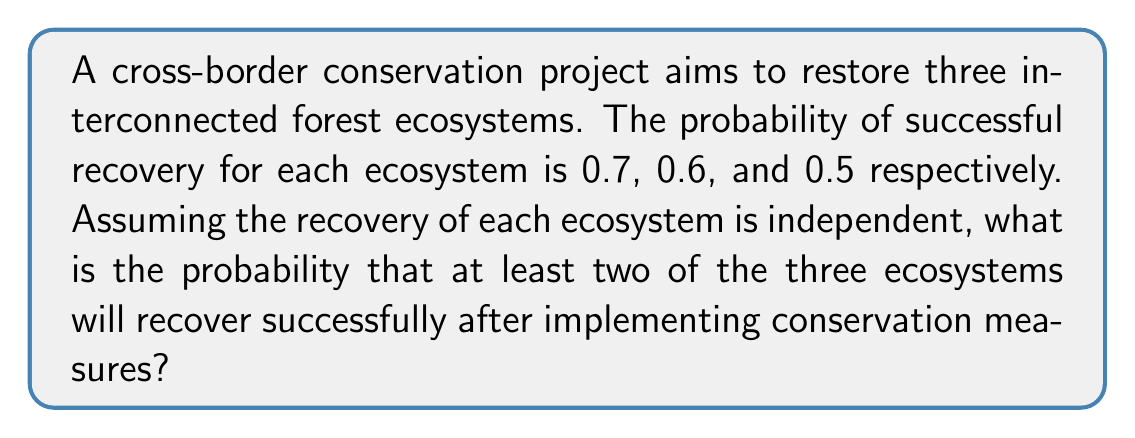Teach me how to tackle this problem. Let's approach this step-by-step:

1) First, we need to calculate the probability of the complement event: the probability that 0 or 1 ecosystem recovers.

2) Let's define the events:
   A: first ecosystem recovers (P(A) = 0.7)
   B: second ecosystem recovers (P(B) = 0.6)
   C: third ecosystem recovers (P(C) = 0.5)

3) Probability of 0 ecosystems recovering:
   $P(\text{none}) = (1-0.7)(1-0.6)(1-0.5) = 0.3 \times 0.4 \times 0.5 = 0.06$

4) Probability of exactly 1 ecosystem recovering:
   $P(\text{one}) = 0.7 \times 0.4 \times 0.5 + 0.3 \times 0.6 \times 0.5 + 0.3 \times 0.4 \times 0.5$
                  $= 0.14 + 0.09 + 0.06 = 0.29$

5) Probability of 0 or 1 ecosystem recovering:
   $P(0 \text{ or } 1) = 0.06 + 0.29 = 0.35$

6) Therefore, the probability of at least 2 ecosystems recovering is the complement of this:
   $P(\text{at least 2}) = 1 - P(0 \text{ or } 1) = 1 - 0.35 = 0.65$
Answer: 0.65 